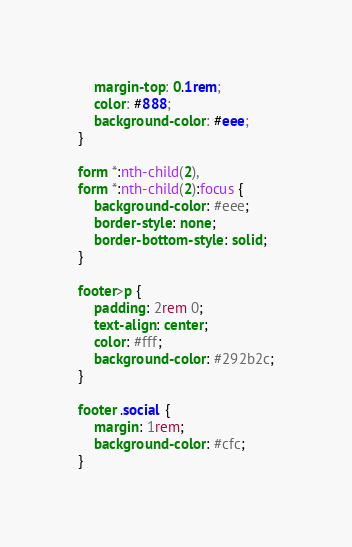Convert code to text. <code><loc_0><loc_0><loc_500><loc_500><_CSS_>    margin-top: 0.1rem;
    color: #888;
    background-color: #eee;
}

form *:nth-child(2),
form *:nth-child(2):focus {
    background-color: #eee;
    border-style: none;
    border-bottom-style: solid;
}

footer>p {
    padding: 2rem 0;
    text-align: center;
    color: #fff;
    background-color: #292b2c;
}

footer .social {
    margin: 1rem;
    background-color: #cfc;
}
</code> 